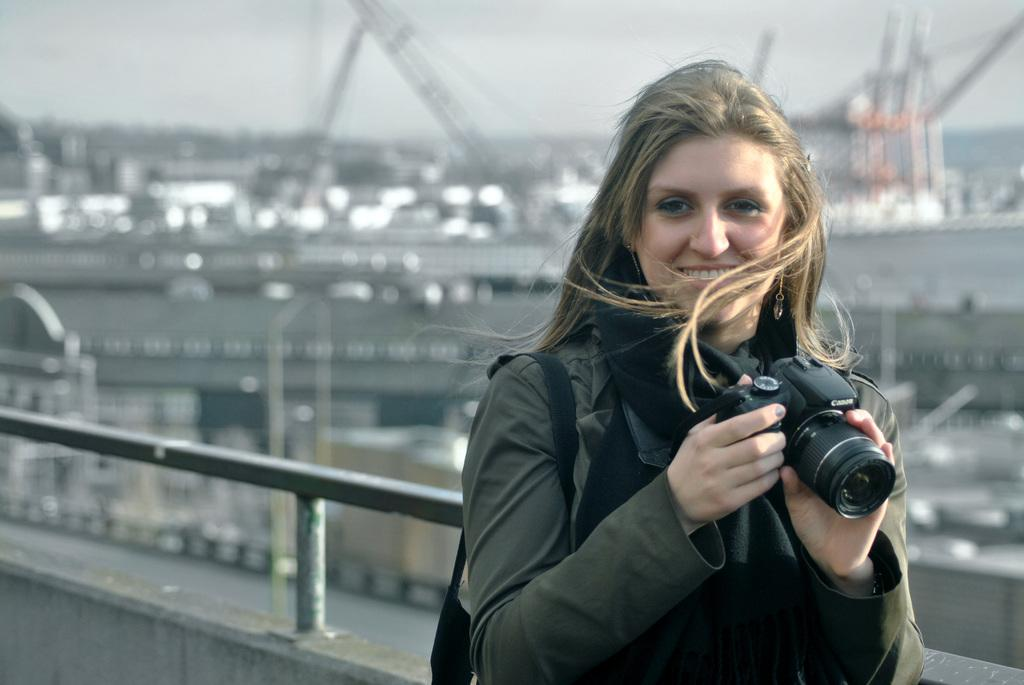What is the main subject of the image? The main subject of the image is a woman. What is the woman holding in the image? The woman is holding a camera in the image. What is the woman's facial expression in the image? The woman is smiling in the image. How many sticks can be seen in the woman's eye in the image? There are no sticks visible in the woman's eye in the image. 